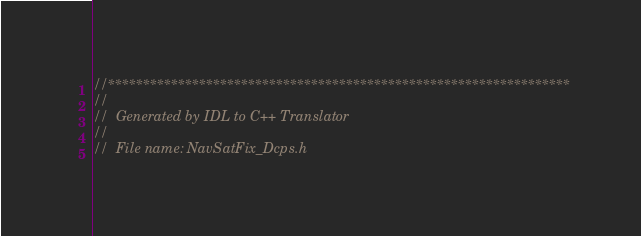<code> <loc_0><loc_0><loc_500><loc_500><_C_>//******************************************************************
// 
//  Generated by IDL to C++ Translator
//  
//  File name: NavSatFix_Dcps.h</code> 